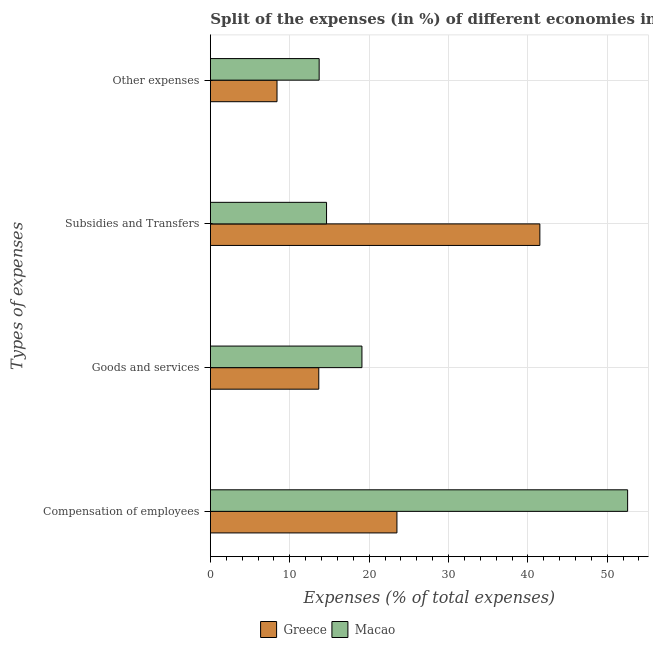How many different coloured bars are there?
Offer a very short reply. 2. Are the number of bars on each tick of the Y-axis equal?
Provide a short and direct response. Yes. How many bars are there on the 4th tick from the top?
Offer a very short reply. 2. What is the label of the 3rd group of bars from the top?
Provide a short and direct response. Goods and services. What is the percentage of amount spent on subsidies in Macao?
Offer a terse response. 14.63. Across all countries, what is the maximum percentage of amount spent on goods and services?
Your answer should be very brief. 19.09. Across all countries, what is the minimum percentage of amount spent on subsidies?
Give a very brief answer. 14.63. In which country was the percentage of amount spent on goods and services maximum?
Make the answer very short. Macao. What is the total percentage of amount spent on other expenses in the graph?
Your answer should be very brief. 22.1. What is the difference between the percentage of amount spent on compensation of employees in Macao and that in Greece?
Your response must be concise. 29.07. What is the difference between the percentage of amount spent on compensation of employees in Macao and the percentage of amount spent on goods and services in Greece?
Give a very brief answer. 38.91. What is the average percentage of amount spent on compensation of employees per country?
Your answer should be compact. 38.04. What is the difference between the percentage of amount spent on goods and services and percentage of amount spent on compensation of employees in Greece?
Keep it short and to the point. -9.85. In how many countries, is the percentage of amount spent on subsidies greater than 6 %?
Make the answer very short. 2. What is the ratio of the percentage of amount spent on compensation of employees in Greece to that in Macao?
Offer a very short reply. 0.45. Is the difference between the percentage of amount spent on subsidies in Macao and Greece greater than the difference between the percentage of amount spent on goods and services in Macao and Greece?
Provide a short and direct response. No. What is the difference between the highest and the second highest percentage of amount spent on goods and services?
Offer a terse response. 5.44. What is the difference between the highest and the lowest percentage of amount spent on other expenses?
Provide a short and direct response. 5.31. In how many countries, is the percentage of amount spent on goods and services greater than the average percentage of amount spent on goods and services taken over all countries?
Offer a terse response. 1. Is the sum of the percentage of amount spent on goods and services in Macao and Greece greater than the maximum percentage of amount spent on other expenses across all countries?
Offer a terse response. Yes. Is it the case that in every country, the sum of the percentage of amount spent on goods and services and percentage of amount spent on compensation of employees is greater than the sum of percentage of amount spent on subsidies and percentage of amount spent on other expenses?
Ensure brevity in your answer.  Yes. How many bars are there?
Provide a succinct answer. 8. Are all the bars in the graph horizontal?
Give a very brief answer. Yes. What is the difference between two consecutive major ticks on the X-axis?
Provide a short and direct response. 10. Are the values on the major ticks of X-axis written in scientific E-notation?
Make the answer very short. No. Does the graph contain grids?
Make the answer very short. Yes. How many legend labels are there?
Give a very brief answer. 2. How are the legend labels stacked?
Provide a succinct answer. Horizontal. What is the title of the graph?
Offer a very short reply. Split of the expenses (in %) of different economies in 2002. Does "Hungary" appear as one of the legend labels in the graph?
Offer a very short reply. No. What is the label or title of the X-axis?
Your answer should be very brief. Expenses (% of total expenses). What is the label or title of the Y-axis?
Your answer should be very brief. Types of expenses. What is the Expenses (% of total expenses) in Greece in Compensation of employees?
Provide a succinct answer. 23.5. What is the Expenses (% of total expenses) of Macao in Compensation of employees?
Ensure brevity in your answer.  52.57. What is the Expenses (% of total expenses) of Greece in Goods and services?
Offer a terse response. 13.66. What is the Expenses (% of total expenses) of Macao in Goods and services?
Ensure brevity in your answer.  19.09. What is the Expenses (% of total expenses) in Greece in Subsidies and Transfers?
Offer a very short reply. 41.51. What is the Expenses (% of total expenses) of Macao in Subsidies and Transfers?
Make the answer very short. 14.63. What is the Expenses (% of total expenses) of Greece in Other expenses?
Make the answer very short. 8.39. What is the Expenses (% of total expenses) of Macao in Other expenses?
Make the answer very short. 13.7. Across all Types of expenses, what is the maximum Expenses (% of total expenses) of Greece?
Your response must be concise. 41.51. Across all Types of expenses, what is the maximum Expenses (% of total expenses) in Macao?
Your answer should be very brief. 52.57. Across all Types of expenses, what is the minimum Expenses (% of total expenses) in Greece?
Provide a succinct answer. 8.39. Across all Types of expenses, what is the minimum Expenses (% of total expenses) of Macao?
Provide a succinct answer. 13.7. What is the total Expenses (% of total expenses) in Greece in the graph?
Make the answer very short. 87.06. What is the difference between the Expenses (% of total expenses) of Greece in Compensation of employees and that in Goods and services?
Ensure brevity in your answer.  9.85. What is the difference between the Expenses (% of total expenses) in Macao in Compensation of employees and that in Goods and services?
Your answer should be very brief. 33.48. What is the difference between the Expenses (% of total expenses) in Greece in Compensation of employees and that in Subsidies and Transfers?
Ensure brevity in your answer.  -18.01. What is the difference between the Expenses (% of total expenses) of Macao in Compensation of employees and that in Subsidies and Transfers?
Offer a terse response. 37.93. What is the difference between the Expenses (% of total expenses) in Greece in Compensation of employees and that in Other expenses?
Provide a short and direct response. 15.11. What is the difference between the Expenses (% of total expenses) of Macao in Compensation of employees and that in Other expenses?
Provide a succinct answer. 38.87. What is the difference between the Expenses (% of total expenses) of Greece in Goods and services and that in Subsidies and Transfers?
Keep it short and to the point. -27.85. What is the difference between the Expenses (% of total expenses) of Macao in Goods and services and that in Subsidies and Transfers?
Your response must be concise. 4.46. What is the difference between the Expenses (% of total expenses) in Greece in Goods and services and that in Other expenses?
Ensure brevity in your answer.  5.26. What is the difference between the Expenses (% of total expenses) of Macao in Goods and services and that in Other expenses?
Keep it short and to the point. 5.39. What is the difference between the Expenses (% of total expenses) of Greece in Subsidies and Transfers and that in Other expenses?
Make the answer very short. 33.12. What is the difference between the Expenses (% of total expenses) in Macao in Subsidies and Transfers and that in Other expenses?
Offer a terse response. 0.93. What is the difference between the Expenses (% of total expenses) of Greece in Compensation of employees and the Expenses (% of total expenses) of Macao in Goods and services?
Provide a short and direct response. 4.41. What is the difference between the Expenses (% of total expenses) of Greece in Compensation of employees and the Expenses (% of total expenses) of Macao in Subsidies and Transfers?
Ensure brevity in your answer.  8.87. What is the difference between the Expenses (% of total expenses) in Greece in Compensation of employees and the Expenses (% of total expenses) in Macao in Other expenses?
Offer a terse response. 9.8. What is the difference between the Expenses (% of total expenses) of Greece in Goods and services and the Expenses (% of total expenses) of Macao in Subsidies and Transfers?
Offer a terse response. -0.98. What is the difference between the Expenses (% of total expenses) in Greece in Goods and services and the Expenses (% of total expenses) in Macao in Other expenses?
Your response must be concise. -0.05. What is the difference between the Expenses (% of total expenses) of Greece in Subsidies and Transfers and the Expenses (% of total expenses) of Macao in Other expenses?
Your response must be concise. 27.81. What is the average Expenses (% of total expenses) of Greece per Types of expenses?
Offer a terse response. 21.77. What is the average Expenses (% of total expenses) of Macao per Types of expenses?
Your response must be concise. 25. What is the difference between the Expenses (% of total expenses) in Greece and Expenses (% of total expenses) in Macao in Compensation of employees?
Your answer should be very brief. -29.07. What is the difference between the Expenses (% of total expenses) in Greece and Expenses (% of total expenses) in Macao in Goods and services?
Your answer should be compact. -5.44. What is the difference between the Expenses (% of total expenses) of Greece and Expenses (% of total expenses) of Macao in Subsidies and Transfers?
Provide a succinct answer. 26.88. What is the difference between the Expenses (% of total expenses) in Greece and Expenses (% of total expenses) in Macao in Other expenses?
Keep it short and to the point. -5.31. What is the ratio of the Expenses (% of total expenses) of Greece in Compensation of employees to that in Goods and services?
Give a very brief answer. 1.72. What is the ratio of the Expenses (% of total expenses) of Macao in Compensation of employees to that in Goods and services?
Give a very brief answer. 2.75. What is the ratio of the Expenses (% of total expenses) of Greece in Compensation of employees to that in Subsidies and Transfers?
Keep it short and to the point. 0.57. What is the ratio of the Expenses (% of total expenses) of Macao in Compensation of employees to that in Subsidies and Transfers?
Make the answer very short. 3.59. What is the ratio of the Expenses (% of total expenses) of Greece in Compensation of employees to that in Other expenses?
Offer a terse response. 2.8. What is the ratio of the Expenses (% of total expenses) of Macao in Compensation of employees to that in Other expenses?
Give a very brief answer. 3.84. What is the ratio of the Expenses (% of total expenses) in Greece in Goods and services to that in Subsidies and Transfers?
Offer a very short reply. 0.33. What is the ratio of the Expenses (% of total expenses) of Macao in Goods and services to that in Subsidies and Transfers?
Ensure brevity in your answer.  1.3. What is the ratio of the Expenses (% of total expenses) in Greece in Goods and services to that in Other expenses?
Make the answer very short. 1.63. What is the ratio of the Expenses (% of total expenses) in Macao in Goods and services to that in Other expenses?
Your answer should be compact. 1.39. What is the ratio of the Expenses (% of total expenses) in Greece in Subsidies and Transfers to that in Other expenses?
Ensure brevity in your answer.  4.95. What is the ratio of the Expenses (% of total expenses) in Macao in Subsidies and Transfers to that in Other expenses?
Give a very brief answer. 1.07. What is the difference between the highest and the second highest Expenses (% of total expenses) in Greece?
Your response must be concise. 18.01. What is the difference between the highest and the second highest Expenses (% of total expenses) in Macao?
Keep it short and to the point. 33.48. What is the difference between the highest and the lowest Expenses (% of total expenses) in Greece?
Your answer should be compact. 33.12. What is the difference between the highest and the lowest Expenses (% of total expenses) in Macao?
Your answer should be very brief. 38.87. 